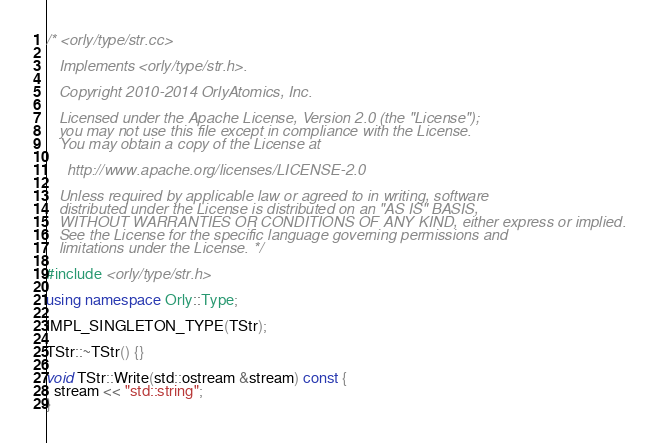Convert code to text. <code><loc_0><loc_0><loc_500><loc_500><_C++_>/* <orly/type/str.cc>

   Implements <orly/type/str.h>.

   Copyright 2010-2014 OrlyAtomics, Inc.

   Licensed under the Apache License, Version 2.0 (the "License");
   you may not use this file except in compliance with the License.
   You may obtain a copy of the License at

     http://www.apache.org/licenses/LICENSE-2.0

   Unless required by applicable law or agreed to in writing, software
   distributed under the License is distributed on an "AS IS" BASIS,
   WITHOUT WARRANTIES OR CONDITIONS OF ANY KIND, either express or implied.
   See the License for the specific language governing permissions and
   limitations under the License. */

#include <orly/type/str.h>

using namespace Orly::Type;

IMPL_SINGLETON_TYPE(TStr);

TStr::~TStr() {}

void TStr::Write(std::ostream &stream) const {
  stream << "std::string";
}</code> 